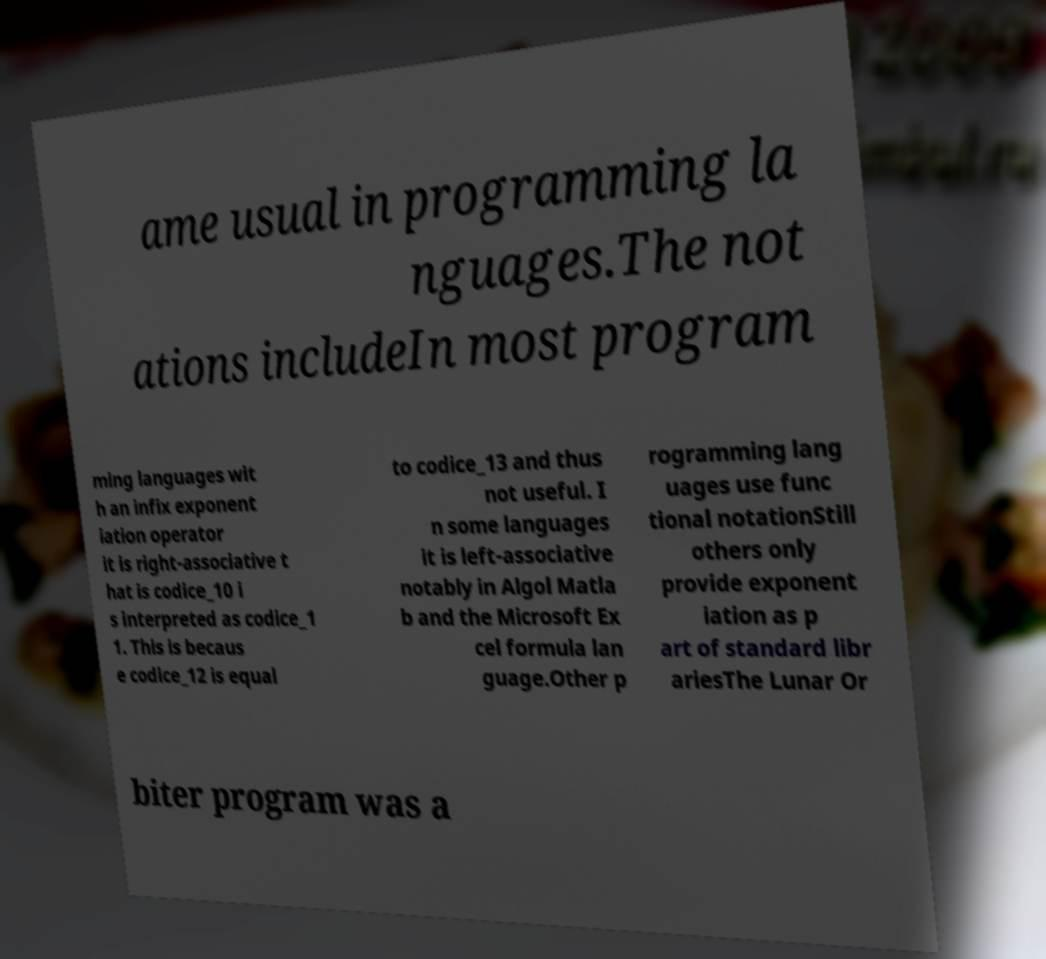Please identify and transcribe the text found in this image. ame usual in programming la nguages.The not ations includeIn most program ming languages wit h an infix exponent iation operator it is right-associative t hat is codice_10 i s interpreted as codice_1 1. This is becaus e codice_12 is equal to codice_13 and thus not useful. I n some languages it is left-associative notably in Algol Matla b and the Microsoft Ex cel formula lan guage.Other p rogramming lang uages use func tional notationStill others only provide exponent iation as p art of standard libr ariesThe Lunar Or biter program was a 